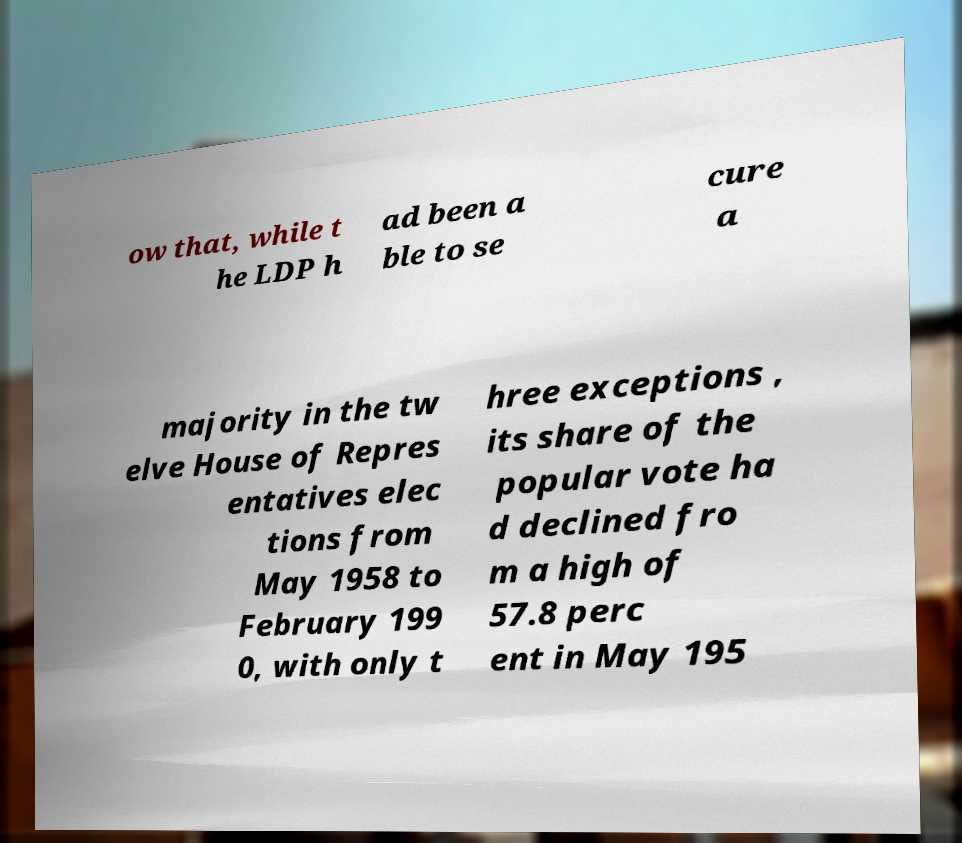Please identify and transcribe the text found in this image. ow that, while t he LDP h ad been a ble to se cure a majority in the tw elve House of Repres entatives elec tions from May 1958 to February 199 0, with only t hree exceptions , its share of the popular vote ha d declined fro m a high of 57.8 perc ent in May 195 